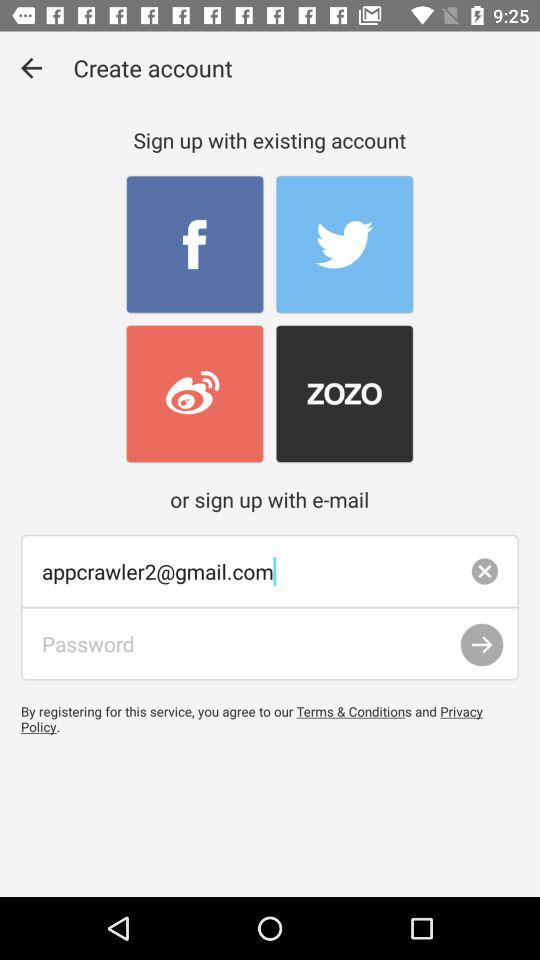What is the email address of the user? The email address of the user is appcrawler2@gmail.com. 